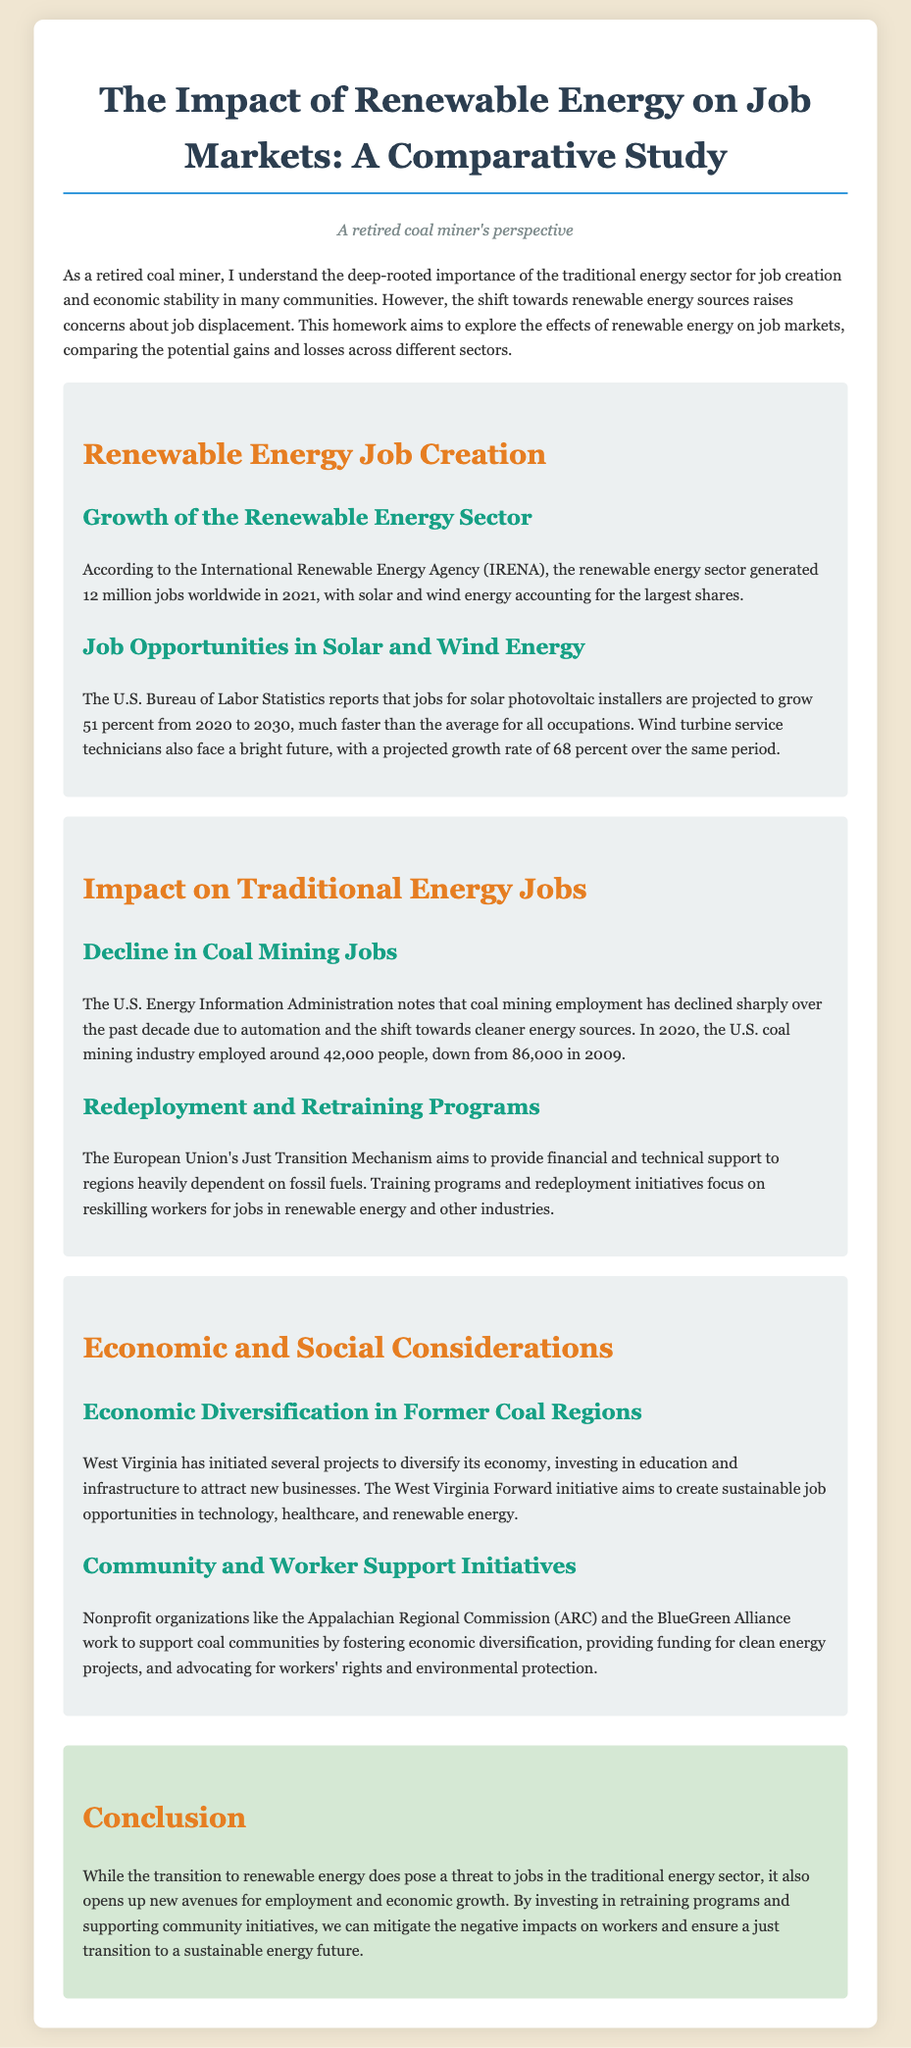What was the number of jobs generated by the renewable energy sector in 2021? The document states that the renewable energy sector generated 12 million jobs worldwide in 2021.
Answer: 12 million What is the projected job growth rate for solar photovoltaic installers from 2020 to 2030? According to the U.S. Bureau of Labor Statistics, jobs for solar photovoltaic installers are projected to grow 51 percent.
Answer: 51 percent How many people were employed in the U.S. coal mining industry in 2020? The U.S. Energy Information Administration notes that the U.S. coal mining industry employed around 42,000 people in 2020.
Answer: 42,000 What initiative aims to support regions dependent on fossil fuels in the European Union? The document mentions the European Union's Just Transition Mechanism as a supportive initiative.
Answer: Just Transition Mechanism What is one project initiated in West Virginia for economic diversification? The West Virginia Forward initiative is mentioned as a project aimed at creating sustainable job opportunities.
Answer: West Virginia Forward How many coal mining jobs were there in 2009? The document states that coal mining jobs were at 86,000 in 2009.
Answer: 86,000 What organization works to support coal communities economically and socially? The document references the Appalachian Regional Commission (ARC) as an organization that provides support.
Answer: Appalachian Regional Commission What is the main focus of retraining programs mentioned in the document? The retraining programs focus on reskilling workers for jobs in renewable energy and other industries.
Answer: Reskilling workers What year is projected for the job growth of wind turbine service technicians? The growth projection period for wind turbine service technicians mentioned is from 2020 to 2030.
Answer: 2020 to 2030 